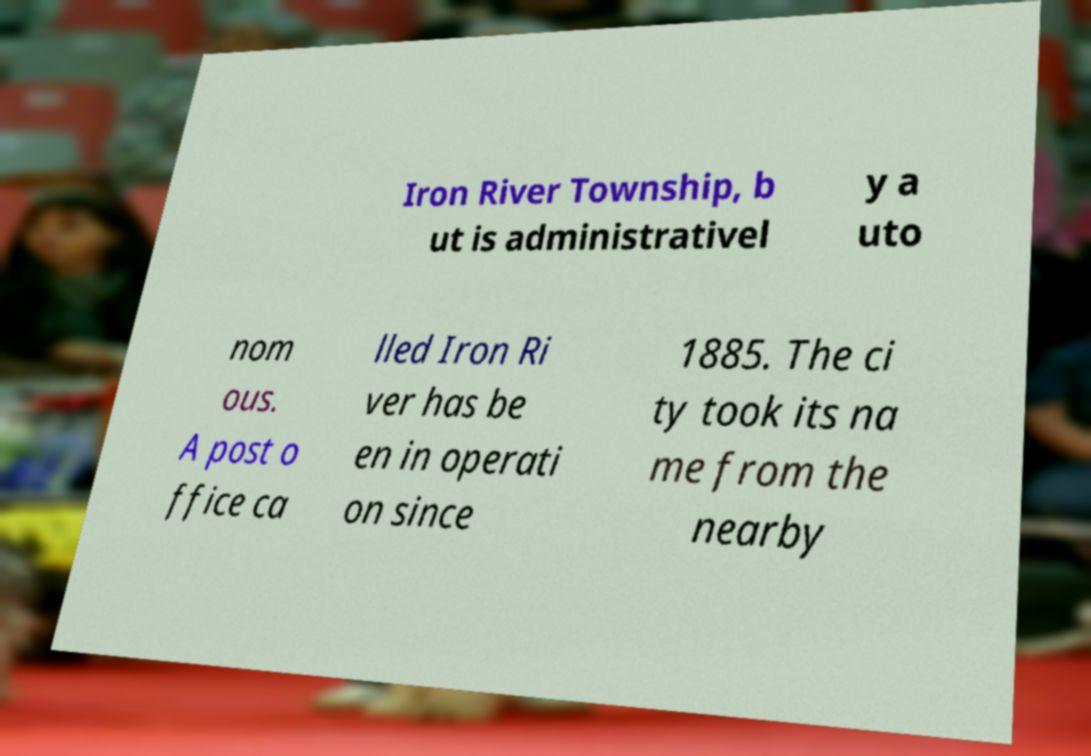Please read and relay the text visible in this image. What does it say? Iron River Township, b ut is administrativel y a uto nom ous. A post o ffice ca lled Iron Ri ver has be en in operati on since 1885. The ci ty took its na me from the nearby 